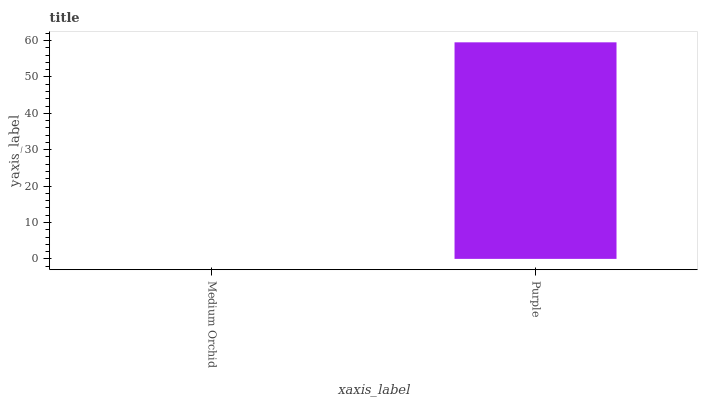Is Medium Orchid the minimum?
Answer yes or no. Yes. Is Purple the maximum?
Answer yes or no. Yes. Is Purple the minimum?
Answer yes or no. No. Is Purple greater than Medium Orchid?
Answer yes or no. Yes. Is Medium Orchid less than Purple?
Answer yes or no. Yes. Is Medium Orchid greater than Purple?
Answer yes or no. No. Is Purple less than Medium Orchid?
Answer yes or no. No. Is Purple the high median?
Answer yes or no. Yes. Is Medium Orchid the low median?
Answer yes or no. Yes. Is Medium Orchid the high median?
Answer yes or no. No. Is Purple the low median?
Answer yes or no. No. 